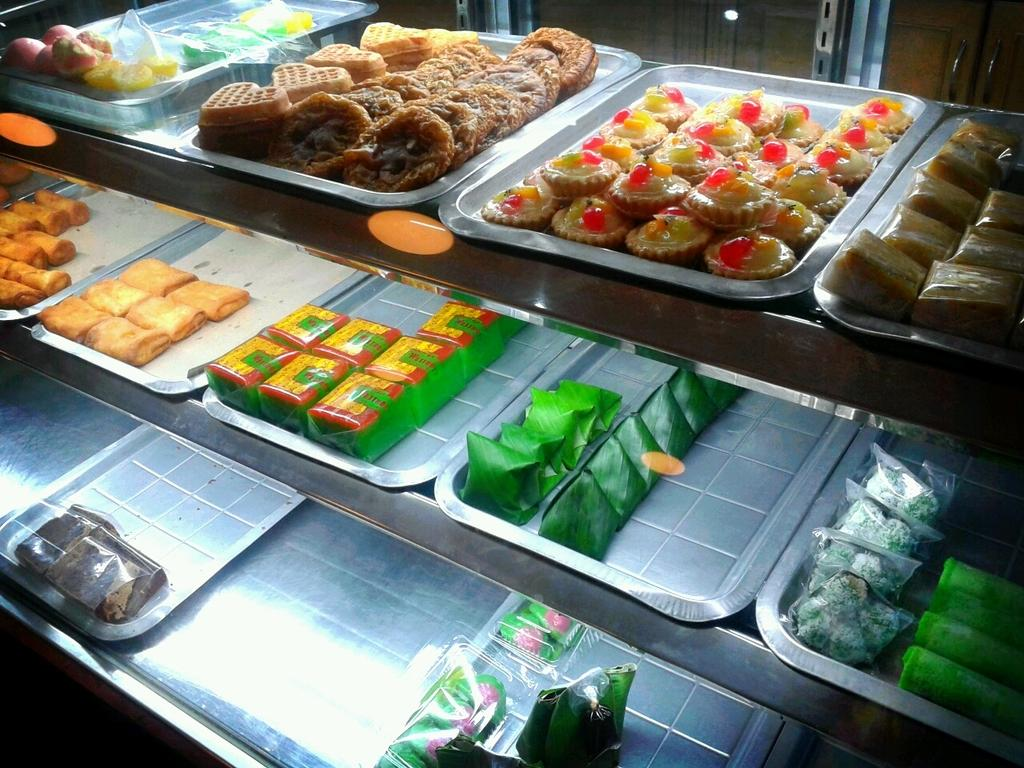What can be seen in the image? There are different food items in the image. How are the food items organized in the image? The food items are placed in trays. How are the trays arranged in the image? The trays are arranged in racks. Can you see any wounds on the food items in the image? There are no wounds visible on the food items in the image. What type of vase is present in the image? There is no vase present in the image; it features different food items arranged in trays on racks. 